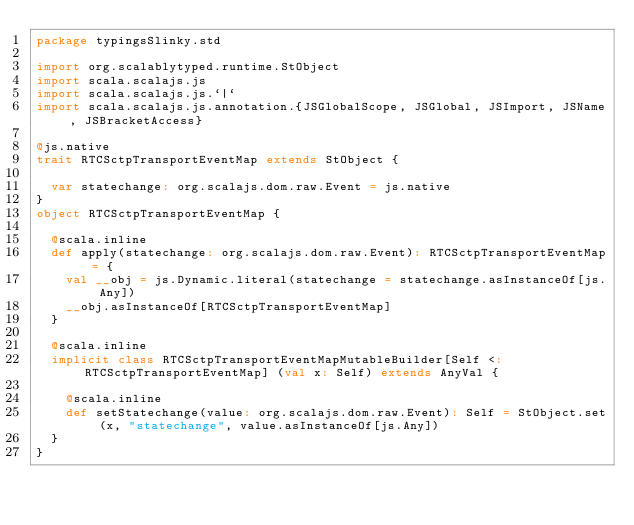Convert code to text. <code><loc_0><loc_0><loc_500><loc_500><_Scala_>package typingsSlinky.std

import org.scalablytyped.runtime.StObject
import scala.scalajs.js
import scala.scalajs.js.`|`
import scala.scalajs.js.annotation.{JSGlobalScope, JSGlobal, JSImport, JSName, JSBracketAccess}

@js.native
trait RTCSctpTransportEventMap extends StObject {
  
  var statechange: org.scalajs.dom.raw.Event = js.native
}
object RTCSctpTransportEventMap {
  
  @scala.inline
  def apply(statechange: org.scalajs.dom.raw.Event): RTCSctpTransportEventMap = {
    val __obj = js.Dynamic.literal(statechange = statechange.asInstanceOf[js.Any])
    __obj.asInstanceOf[RTCSctpTransportEventMap]
  }
  
  @scala.inline
  implicit class RTCSctpTransportEventMapMutableBuilder[Self <: RTCSctpTransportEventMap] (val x: Self) extends AnyVal {
    
    @scala.inline
    def setStatechange(value: org.scalajs.dom.raw.Event): Self = StObject.set(x, "statechange", value.asInstanceOf[js.Any])
  }
}
</code> 